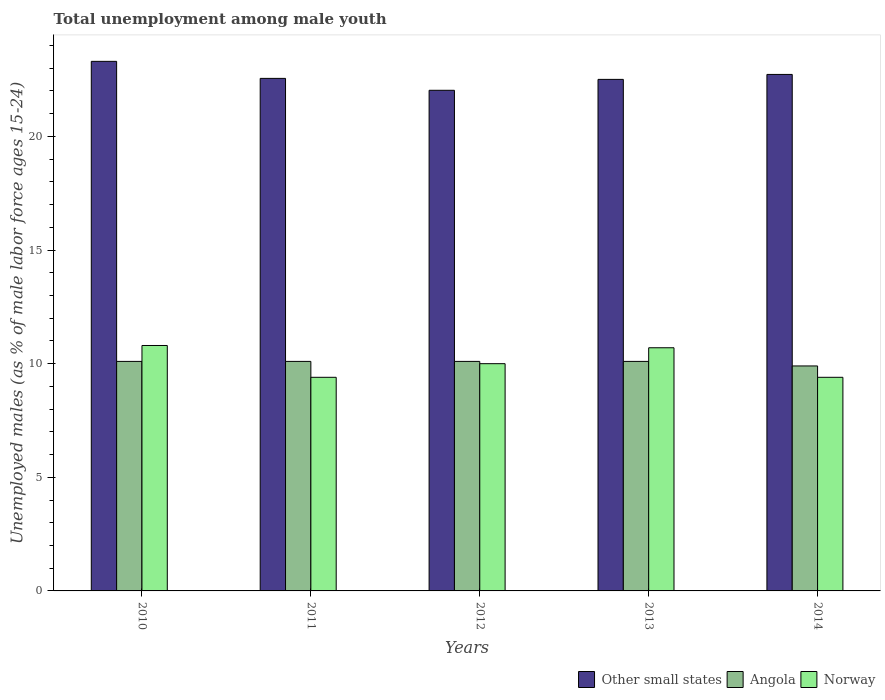How many different coloured bars are there?
Provide a short and direct response. 3. How many groups of bars are there?
Offer a very short reply. 5. Are the number of bars per tick equal to the number of legend labels?
Ensure brevity in your answer.  Yes. Are the number of bars on each tick of the X-axis equal?
Offer a terse response. Yes. How many bars are there on the 4th tick from the left?
Offer a very short reply. 3. How many bars are there on the 4th tick from the right?
Ensure brevity in your answer.  3. In how many cases, is the number of bars for a given year not equal to the number of legend labels?
Provide a succinct answer. 0. What is the percentage of unemployed males in in Other small states in 2010?
Offer a very short reply. 23.3. Across all years, what is the maximum percentage of unemployed males in in Other small states?
Make the answer very short. 23.3. Across all years, what is the minimum percentage of unemployed males in in Angola?
Offer a terse response. 9.9. In which year was the percentage of unemployed males in in Other small states maximum?
Your answer should be compact. 2010. What is the total percentage of unemployed males in in Angola in the graph?
Your answer should be very brief. 50.3. What is the difference between the percentage of unemployed males in in Other small states in 2011 and that in 2013?
Offer a terse response. 0.04. What is the difference between the percentage of unemployed males in in Norway in 2011 and the percentage of unemployed males in in Angola in 2013?
Offer a terse response. -0.7. What is the average percentage of unemployed males in in Angola per year?
Keep it short and to the point. 10.06. In the year 2011, what is the difference between the percentage of unemployed males in in Angola and percentage of unemployed males in in Norway?
Your answer should be compact. 0.7. In how many years, is the percentage of unemployed males in in Norway greater than 16 %?
Offer a very short reply. 0. What is the ratio of the percentage of unemployed males in in Angola in 2011 to that in 2012?
Provide a short and direct response. 1. Is the difference between the percentage of unemployed males in in Angola in 2013 and 2014 greater than the difference between the percentage of unemployed males in in Norway in 2013 and 2014?
Provide a succinct answer. No. What is the difference between the highest and the second highest percentage of unemployed males in in Norway?
Offer a terse response. 0.1. What is the difference between the highest and the lowest percentage of unemployed males in in Norway?
Give a very brief answer. 1.4. What does the 1st bar from the right in 2012 represents?
Make the answer very short. Norway. Is it the case that in every year, the sum of the percentage of unemployed males in in Other small states and percentage of unemployed males in in Norway is greater than the percentage of unemployed males in in Angola?
Your response must be concise. Yes. How many years are there in the graph?
Give a very brief answer. 5. What is the difference between two consecutive major ticks on the Y-axis?
Provide a short and direct response. 5. Does the graph contain grids?
Provide a short and direct response. No. Where does the legend appear in the graph?
Offer a very short reply. Bottom right. How are the legend labels stacked?
Give a very brief answer. Horizontal. What is the title of the graph?
Make the answer very short. Total unemployment among male youth. Does "Tonga" appear as one of the legend labels in the graph?
Offer a very short reply. No. What is the label or title of the Y-axis?
Provide a short and direct response. Unemployed males (as % of male labor force ages 15-24). What is the Unemployed males (as % of male labor force ages 15-24) of Other small states in 2010?
Offer a terse response. 23.3. What is the Unemployed males (as % of male labor force ages 15-24) of Angola in 2010?
Provide a succinct answer. 10.1. What is the Unemployed males (as % of male labor force ages 15-24) in Norway in 2010?
Your answer should be compact. 10.8. What is the Unemployed males (as % of male labor force ages 15-24) in Other small states in 2011?
Offer a very short reply. 22.55. What is the Unemployed males (as % of male labor force ages 15-24) in Angola in 2011?
Make the answer very short. 10.1. What is the Unemployed males (as % of male labor force ages 15-24) of Norway in 2011?
Keep it short and to the point. 9.4. What is the Unemployed males (as % of male labor force ages 15-24) in Other small states in 2012?
Offer a terse response. 22.03. What is the Unemployed males (as % of male labor force ages 15-24) in Angola in 2012?
Give a very brief answer. 10.1. What is the Unemployed males (as % of male labor force ages 15-24) of Norway in 2012?
Provide a short and direct response. 10. What is the Unemployed males (as % of male labor force ages 15-24) of Other small states in 2013?
Your answer should be compact. 22.51. What is the Unemployed males (as % of male labor force ages 15-24) in Angola in 2013?
Provide a short and direct response. 10.1. What is the Unemployed males (as % of male labor force ages 15-24) of Norway in 2013?
Offer a terse response. 10.7. What is the Unemployed males (as % of male labor force ages 15-24) in Other small states in 2014?
Your answer should be very brief. 22.73. What is the Unemployed males (as % of male labor force ages 15-24) in Angola in 2014?
Your answer should be very brief. 9.9. What is the Unemployed males (as % of male labor force ages 15-24) in Norway in 2014?
Keep it short and to the point. 9.4. Across all years, what is the maximum Unemployed males (as % of male labor force ages 15-24) in Other small states?
Keep it short and to the point. 23.3. Across all years, what is the maximum Unemployed males (as % of male labor force ages 15-24) in Angola?
Your answer should be very brief. 10.1. Across all years, what is the maximum Unemployed males (as % of male labor force ages 15-24) of Norway?
Offer a terse response. 10.8. Across all years, what is the minimum Unemployed males (as % of male labor force ages 15-24) of Other small states?
Make the answer very short. 22.03. Across all years, what is the minimum Unemployed males (as % of male labor force ages 15-24) in Angola?
Your response must be concise. 9.9. Across all years, what is the minimum Unemployed males (as % of male labor force ages 15-24) of Norway?
Keep it short and to the point. 9.4. What is the total Unemployed males (as % of male labor force ages 15-24) in Other small states in the graph?
Your response must be concise. 113.13. What is the total Unemployed males (as % of male labor force ages 15-24) of Angola in the graph?
Offer a very short reply. 50.3. What is the total Unemployed males (as % of male labor force ages 15-24) in Norway in the graph?
Provide a succinct answer. 50.3. What is the difference between the Unemployed males (as % of male labor force ages 15-24) of Other small states in 2010 and that in 2011?
Your answer should be very brief. 0.75. What is the difference between the Unemployed males (as % of male labor force ages 15-24) of Angola in 2010 and that in 2011?
Make the answer very short. 0. What is the difference between the Unemployed males (as % of male labor force ages 15-24) in Norway in 2010 and that in 2011?
Offer a terse response. 1.4. What is the difference between the Unemployed males (as % of male labor force ages 15-24) in Other small states in 2010 and that in 2012?
Offer a terse response. 1.27. What is the difference between the Unemployed males (as % of male labor force ages 15-24) of Angola in 2010 and that in 2012?
Offer a very short reply. 0. What is the difference between the Unemployed males (as % of male labor force ages 15-24) in Other small states in 2010 and that in 2013?
Your answer should be compact. 0.79. What is the difference between the Unemployed males (as % of male labor force ages 15-24) in Other small states in 2010 and that in 2014?
Offer a very short reply. 0.58. What is the difference between the Unemployed males (as % of male labor force ages 15-24) of Angola in 2010 and that in 2014?
Offer a very short reply. 0.2. What is the difference between the Unemployed males (as % of male labor force ages 15-24) of Norway in 2010 and that in 2014?
Make the answer very short. 1.4. What is the difference between the Unemployed males (as % of male labor force ages 15-24) in Other small states in 2011 and that in 2012?
Make the answer very short. 0.52. What is the difference between the Unemployed males (as % of male labor force ages 15-24) in Norway in 2011 and that in 2012?
Your answer should be compact. -0.6. What is the difference between the Unemployed males (as % of male labor force ages 15-24) in Other small states in 2011 and that in 2013?
Offer a terse response. 0.04. What is the difference between the Unemployed males (as % of male labor force ages 15-24) of Angola in 2011 and that in 2013?
Ensure brevity in your answer.  0. What is the difference between the Unemployed males (as % of male labor force ages 15-24) of Other small states in 2011 and that in 2014?
Keep it short and to the point. -0.17. What is the difference between the Unemployed males (as % of male labor force ages 15-24) in Angola in 2011 and that in 2014?
Your response must be concise. 0.2. What is the difference between the Unemployed males (as % of male labor force ages 15-24) of Norway in 2011 and that in 2014?
Give a very brief answer. 0. What is the difference between the Unemployed males (as % of male labor force ages 15-24) in Other small states in 2012 and that in 2013?
Your answer should be compact. -0.48. What is the difference between the Unemployed males (as % of male labor force ages 15-24) in Norway in 2012 and that in 2013?
Your answer should be very brief. -0.7. What is the difference between the Unemployed males (as % of male labor force ages 15-24) of Other small states in 2012 and that in 2014?
Your response must be concise. -0.7. What is the difference between the Unemployed males (as % of male labor force ages 15-24) of Angola in 2012 and that in 2014?
Provide a succinct answer. 0.2. What is the difference between the Unemployed males (as % of male labor force ages 15-24) in Norway in 2012 and that in 2014?
Provide a short and direct response. 0.6. What is the difference between the Unemployed males (as % of male labor force ages 15-24) of Other small states in 2013 and that in 2014?
Offer a very short reply. -0.22. What is the difference between the Unemployed males (as % of male labor force ages 15-24) of Norway in 2013 and that in 2014?
Provide a short and direct response. 1.3. What is the difference between the Unemployed males (as % of male labor force ages 15-24) in Other small states in 2010 and the Unemployed males (as % of male labor force ages 15-24) in Angola in 2011?
Your answer should be very brief. 13.2. What is the difference between the Unemployed males (as % of male labor force ages 15-24) in Other small states in 2010 and the Unemployed males (as % of male labor force ages 15-24) in Norway in 2011?
Make the answer very short. 13.9. What is the difference between the Unemployed males (as % of male labor force ages 15-24) in Angola in 2010 and the Unemployed males (as % of male labor force ages 15-24) in Norway in 2011?
Your response must be concise. 0.7. What is the difference between the Unemployed males (as % of male labor force ages 15-24) of Other small states in 2010 and the Unemployed males (as % of male labor force ages 15-24) of Angola in 2012?
Provide a short and direct response. 13.2. What is the difference between the Unemployed males (as % of male labor force ages 15-24) in Other small states in 2010 and the Unemployed males (as % of male labor force ages 15-24) in Norway in 2012?
Your answer should be very brief. 13.3. What is the difference between the Unemployed males (as % of male labor force ages 15-24) of Angola in 2010 and the Unemployed males (as % of male labor force ages 15-24) of Norway in 2012?
Offer a terse response. 0.1. What is the difference between the Unemployed males (as % of male labor force ages 15-24) of Other small states in 2010 and the Unemployed males (as % of male labor force ages 15-24) of Angola in 2013?
Provide a short and direct response. 13.2. What is the difference between the Unemployed males (as % of male labor force ages 15-24) of Other small states in 2010 and the Unemployed males (as % of male labor force ages 15-24) of Norway in 2013?
Your response must be concise. 12.6. What is the difference between the Unemployed males (as % of male labor force ages 15-24) of Other small states in 2010 and the Unemployed males (as % of male labor force ages 15-24) of Angola in 2014?
Offer a very short reply. 13.4. What is the difference between the Unemployed males (as % of male labor force ages 15-24) of Other small states in 2010 and the Unemployed males (as % of male labor force ages 15-24) of Norway in 2014?
Keep it short and to the point. 13.9. What is the difference between the Unemployed males (as % of male labor force ages 15-24) in Other small states in 2011 and the Unemployed males (as % of male labor force ages 15-24) in Angola in 2012?
Make the answer very short. 12.45. What is the difference between the Unemployed males (as % of male labor force ages 15-24) of Other small states in 2011 and the Unemployed males (as % of male labor force ages 15-24) of Norway in 2012?
Offer a terse response. 12.55. What is the difference between the Unemployed males (as % of male labor force ages 15-24) in Other small states in 2011 and the Unemployed males (as % of male labor force ages 15-24) in Angola in 2013?
Your answer should be very brief. 12.45. What is the difference between the Unemployed males (as % of male labor force ages 15-24) of Other small states in 2011 and the Unemployed males (as % of male labor force ages 15-24) of Norway in 2013?
Provide a short and direct response. 11.85. What is the difference between the Unemployed males (as % of male labor force ages 15-24) of Other small states in 2011 and the Unemployed males (as % of male labor force ages 15-24) of Angola in 2014?
Offer a very short reply. 12.65. What is the difference between the Unemployed males (as % of male labor force ages 15-24) of Other small states in 2011 and the Unemployed males (as % of male labor force ages 15-24) of Norway in 2014?
Offer a very short reply. 13.15. What is the difference between the Unemployed males (as % of male labor force ages 15-24) of Other small states in 2012 and the Unemployed males (as % of male labor force ages 15-24) of Angola in 2013?
Give a very brief answer. 11.93. What is the difference between the Unemployed males (as % of male labor force ages 15-24) of Other small states in 2012 and the Unemployed males (as % of male labor force ages 15-24) of Norway in 2013?
Provide a short and direct response. 11.33. What is the difference between the Unemployed males (as % of male labor force ages 15-24) of Angola in 2012 and the Unemployed males (as % of male labor force ages 15-24) of Norway in 2013?
Offer a very short reply. -0.6. What is the difference between the Unemployed males (as % of male labor force ages 15-24) of Other small states in 2012 and the Unemployed males (as % of male labor force ages 15-24) of Angola in 2014?
Your answer should be compact. 12.13. What is the difference between the Unemployed males (as % of male labor force ages 15-24) in Other small states in 2012 and the Unemployed males (as % of male labor force ages 15-24) in Norway in 2014?
Make the answer very short. 12.63. What is the difference between the Unemployed males (as % of male labor force ages 15-24) in Angola in 2012 and the Unemployed males (as % of male labor force ages 15-24) in Norway in 2014?
Your answer should be compact. 0.7. What is the difference between the Unemployed males (as % of male labor force ages 15-24) in Other small states in 2013 and the Unemployed males (as % of male labor force ages 15-24) in Angola in 2014?
Offer a terse response. 12.61. What is the difference between the Unemployed males (as % of male labor force ages 15-24) of Other small states in 2013 and the Unemployed males (as % of male labor force ages 15-24) of Norway in 2014?
Your response must be concise. 13.11. What is the difference between the Unemployed males (as % of male labor force ages 15-24) of Angola in 2013 and the Unemployed males (as % of male labor force ages 15-24) of Norway in 2014?
Your response must be concise. 0.7. What is the average Unemployed males (as % of male labor force ages 15-24) of Other small states per year?
Give a very brief answer. 22.63. What is the average Unemployed males (as % of male labor force ages 15-24) of Angola per year?
Provide a short and direct response. 10.06. What is the average Unemployed males (as % of male labor force ages 15-24) in Norway per year?
Make the answer very short. 10.06. In the year 2010, what is the difference between the Unemployed males (as % of male labor force ages 15-24) of Other small states and Unemployed males (as % of male labor force ages 15-24) of Angola?
Offer a very short reply. 13.2. In the year 2010, what is the difference between the Unemployed males (as % of male labor force ages 15-24) of Other small states and Unemployed males (as % of male labor force ages 15-24) of Norway?
Keep it short and to the point. 12.5. In the year 2010, what is the difference between the Unemployed males (as % of male labor force ages 15-24) in Angola and Unemployed males (as % of male labor force ages 15-24) in Norway?
Make the answer very short. -0.7. In the year 2011, what is the difference between the Unemployed males (as % of male labor force ages 15-24) in Other small states and Unemployed males (as % of male labor force ages 15-24) in Angola?
Give a very brief answer. 12.45. In the year 2011, what is the difference between the Unemployed males (as % of male labor force ages 15-24) of Other small states and Unemployed males (as % of male labor force ages 15-24) of Norway?
Your answer should be very brief. 13.15. In the year 2012, what is the difference between the Unemployed males (as % of male labor force ages 15-24) of Other small states and Unemployed males (as % of male labor force ages 15-24) of Angola?
Provide a succinct answer. 11.93. In the year 2012, what is the difference between the Unemployed males (as % of male labor force ages 15-24) in Other small states and Unemployed males (as % of male labor force ages 15-24) in Norway?
Ensure brevity in your answer.  12.03. In the year 2013, what is the difference between the Unemployed males (as % of male labor force ages 15-24) in Other small states and Unemployed males (as % of male labor force ages 15-24) in Angola?
Your response must be concise. 12.41. In the year 2013, what is the difference between the Unemployed males (as % of male labor force ages 15-24) in Other small states and Unemployed males (as % of male labor force ages 15-24) in Norway?
Keep it short and to the point. 11.81. In the year 2014, what is the difference between the Unemployed males (as % of male labor force ages 15-24) in Other small states and Unemployed males (as % of male labor force ages 15-24) in Angola?
Your answer should be compact. 12.83. In the year 2014, what is the difference between the Unemployed males (as % of male labor force ages 15-24) in Other small states and Unemployed males (as % of male labor force ages 15-24) in Norway?
Your response must be concise. 13.33. What is the ratio of the Unemployed males (as % of male labor force ages 15-24) of Other small states in 2010 to that in 2011?
Ensure brevity in your answer.  1.03. What is the ratio of the Unemployed males (as % of male labor force ages 15-24) in Norway in 2010 to that in 2011?
Your response must be concise. 1.15. What is the ratio of the Unemployed males (as % of male labor force ages 15-24) of Other small states in 2010 to that in 2012?
Your answer should be compact. 1.06. What is the ratio of the Unemployed males (as % of male labor force ages 15-24) of Angola in 2010 to that in 2012?
Your answer should be compact. 1. What is the ratio of the Unemployed males (as % of male labor force ages 15-24) of Other small states in 2010 to that in 2013?
Your answer should be very brief. 1.04. What is the ratio of the Unemployed males (as % of male labor force ages 15-24) in Angola in 2010 to that in 2013?
Your answer should be very brief. 1. What is the ratio of the Unemployed males (as % of male labor force ages 15-24) in Norway in 2010 to that in 2013?
Offer a very short reply. 1.01. What is the ratio of the Unemployed males (as % of male labor force ages 15-24) of Other small states in 2010 to that in 2014?
Ensure brevity in your answer.  1.03. What is the ratio of the Unemployed males (as % of male labor force ages 15-24) of Angola in 2010 to that in 2014?
Offer a terse response. 1.02. What is the ratio of the Unemployed males (as % of male labor force ages 15-24) of Norway in 2010 to that in 2014?
Your answer should be very brief. 1.15. What is the ratio of the Unemployed males (as % of male labor force ages 15-24) in Other small states in 2011 to that in 2012?
Provide a succinct answer. 1.02. What is the ratio of the Unemployed males (as % of male labor force ages 15-24) of Norway in 2011 to that in 2012?
Give a very brief answer. 0.94. What is the ratio of the Unemployed males (as % of male labor force ages 15-24) of Other small states in 2011 to that in 2013?
Keep it short and to the point. 1. What is the ratio of the Unemployed males (as % of male labor force ages 15-24) of Angola in 2011 to that in 2013?
Your response must be concise. 1. What is the ratio of the Unemployed males (as % of male labor force ages 15-24) of Norway in 2011 to that in 2013?
Give a very brief answer. 0.88. What is the ratio of the Unemployed males (as % of male labor force ages 15-24) in Angola in 2011 to that in 2014?
Provide a succinct answer. 1.02. What is the ratio of the Unemployed males (as % of male labor force ages 15-24) in Other small states in 2012 to that in 2013?
Make the answer very short. 0.98. What is the ratio of the Unemployed males (as % of male labor force ages 15-24) in Angola in 2012 to that in 2013?
Make the answer very short. 1. What is the ratio of the Unemployed males (as % of male labor force ages 15-24) in Norway in 2012 to that in 2013?
Provide a succinct answer. 0.93. What is the ratio of the Unemployed males (as % of male labor force ages 15-24) of Other small states in 2012 to that in 2014?
Offer a very short reply. 0.97. What is the ratio of the Unemployed males (as % of male labor force ages 15-24) in Angola in 2012 to that in 2014?
Ensure brevity in your answer.  1.02. What is the ratio of the Unemployed males (as % of male labor force ages 15-24) in Norway in 2012 to that in 2014?
Your answer should be very brief. 1.06. What is the ratio of the Unemployed males (as % of male labor force ages 15-24) of Angola in 2013 to that in 2014?
Your response must be concise. 1.02. What is the ratio of the Unemployed males (as % of male labor force ages 15-24) in Norway in 2013 to that in 2014?
Offer a very short reply. 1.14. What is the difference between the highest and the second highest Unemployed males (as % of male labor force ages 15-24) in Other small states?
Make the answer very short. 0.58. What is the difference between the highest and the second highest Unemployed males (as % of male labor force ages 15-24) of Angola?
Offer a very short reply. 0. What is the difference between the highest and the second highest Unemployed males (as % of male labor force ages 15-24) in Norway?
Provide a short and direct response. 0.1. What is the difference between the highest and the lowest Unemployed males (as % of male labor force ages 15-24) in Other small states?
Your answer should be compact. 1.27. What is the difference between the highest and the lowest Unemployed males (as % of male labor force ages 15-24) in Norway?
Your answer should be very brief. 1.4. 